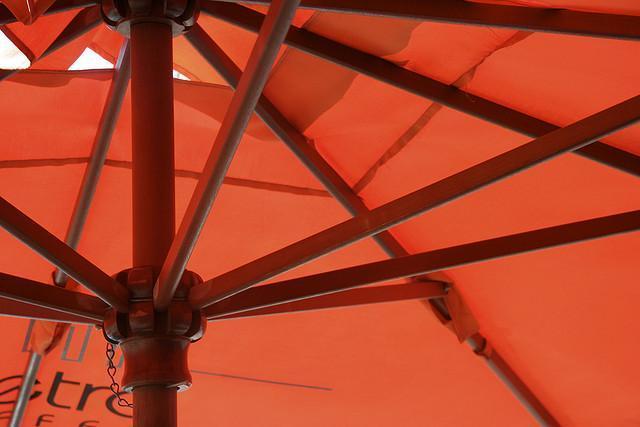How many hot dogs in total?
Give a very brief answer. 0. 